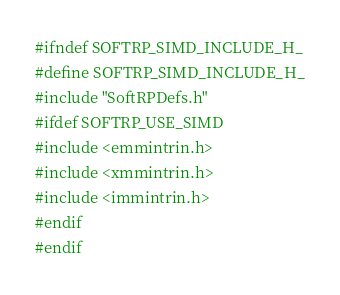Convert code to text. <code><loc_0><loc_0><loc_500><loc_500><_C_>#ifndef SOFTRP_SIMD_INCLUDE_H_
#define SOFTRP_SIMD_INCLUDE_H_
#include "SoftRPDefs.h"
#ifdef SOFTRP_USE_SIMD
#include <emmintrin.h>
#include <xmmintrin.h>
#include <immintrin.h>
#endif
#endif
</code> 